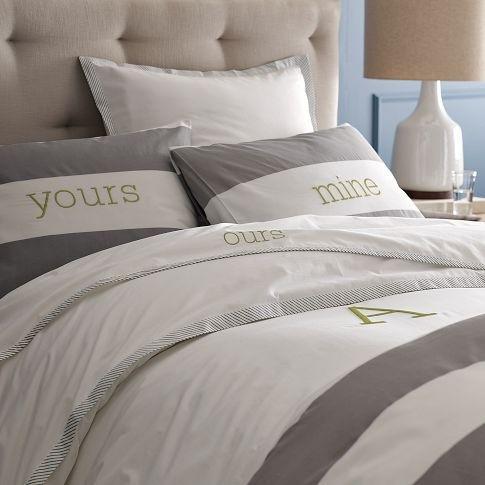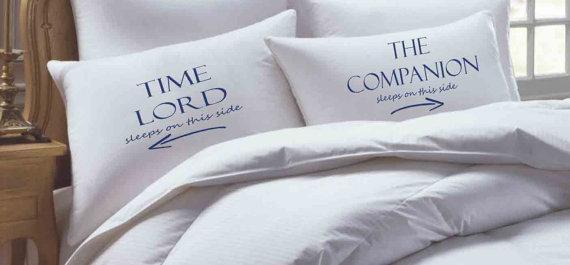The first image is the image on the left, the second image is the image on the right. For the images shown, is this caption "Pillows in both of the images have words written on them." true? Answer yes or no. Yes. The first image is the image on the left, the second image is the image on the right. For the images shown, is this caption "The right image shows a bed with a white comforter and side-by-side white pillows printed with non-cursive dark letters, propped atop plain white pillows." true? Answer yes or no. Yes. 